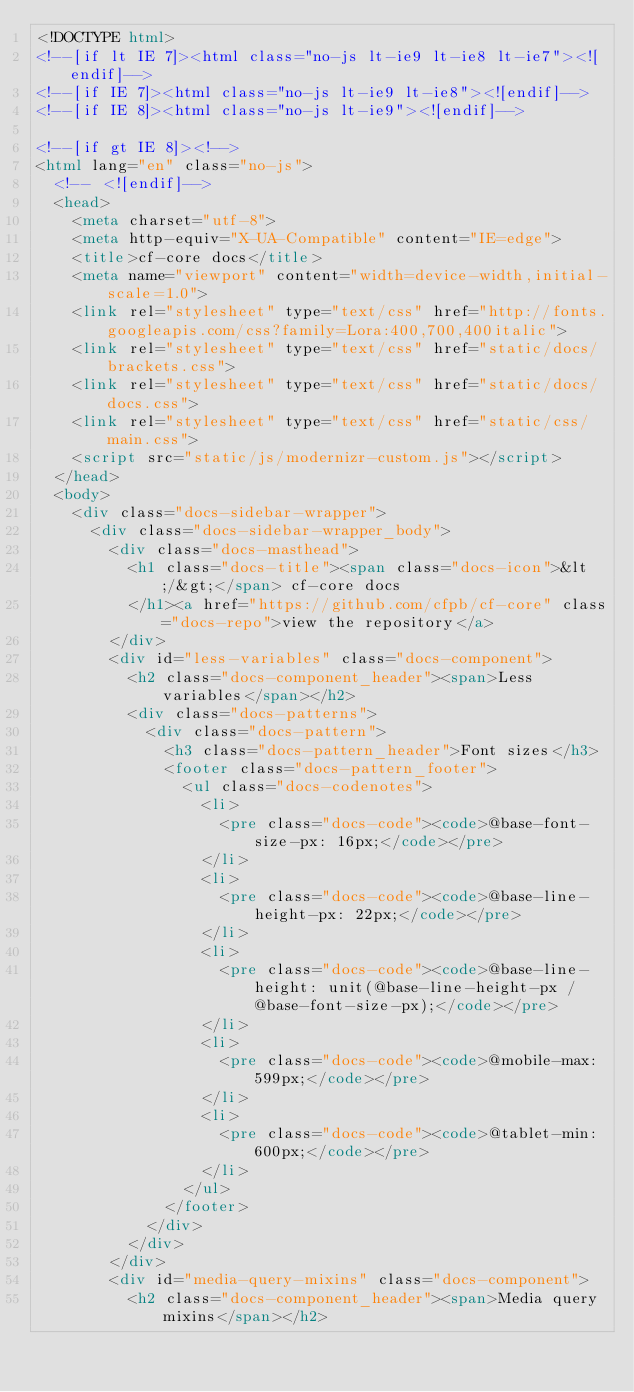Convert code to text. <code><loc_0><loc_0><loc_500><loc_500><_HTML_><!DOCTYPE html>
<!--[if lt IE 7]><html class="no-js lt-ie9 lt-ie8 lt-ie7"><![endif]-->
<!--[if IE 7]><html class="no-js lt-ie9 lt-ie8"><![endif]-->
<!--[if IE 8]><html class="no-js lt-ie9"><![endif]-->

<!--[if gt IE 8]><!-->
<html lang="en" class="no-js">
  <!-- <![endif]-->
  <head>
    <meta charset="utf-8">
    <meta http-equiv="X-UA-Compatible" content="IE=edge">
    <title>cf-core docs</title>
    <meta name="viewport" content="width=device-width,initial-scale=1.0">
    <link rel="stylesheet" type="text/css" href="http://fonts.googleapis.com/css?family=Lora:400,700,400italic">
    <link rel="stylesheet" type="text/css" href="static/docs/brackets.css">
    <link rel="stylesheet" type="text/css" href="static/docs/docs.css">
    <link rel="stylesheet" type="text/css" href="static/css/main.css">
    <script src="static/js/modernizr-custom.js"></script>
  </head>
  <body>
    <div class="docs-sidebar-wrapper">
      <div class="docs-sidebar-wrapper_body">
        <div class="docs-masthead">
          <h1 class="docs-title"><span class="docs-icon">&lt;/&gt;</span> cf-core docs
          </h1><a href="https://github.com/cfpb/cf-core" class="docs-repo">view the repository</a>
        </div>
        <div id="less-variables" class="docs-component">
          <h2 class="docs-component_header"><span>Less variables</span></h2>
          <div class="docs-patterns">
            <div class="docs-pattern">
              <h3 class="docs-pattern_header">Font sizes</h3>
              <footer class="docs-pattern_footer">
                <ul class="docs-codenotes">
                  <li>
                    <pre class="docs-code"><code>@base-font-size-px: 16px;</code></pre>
                  </li>
                  <li>
                    <pre class="docs-code"><code>@base-line-height-px: 22px;</code></pre>
                  </li>
                  <li>
                    <pre class="docs-code"><code>@base-line-height: unit(@base-line-height-px / @base-font-size-px);</code></pre>
                  </li>
                  <li>
                    <pre class="docs-code"><code>@mobile-max: 599px;</code></pre>
                  </li>
                  <li>
                    <pre class="docs-code"><code>@tablet-min: 600px;</code></pre>
                  </li>
                </ul>
              </footer>
            </div>
          </div>
        </div>
        <div id="media-query-mixins" class="docs-component">
          <h2 class="docs-component_header"><span>Media query mixins</span></h2></code> 